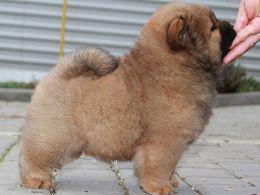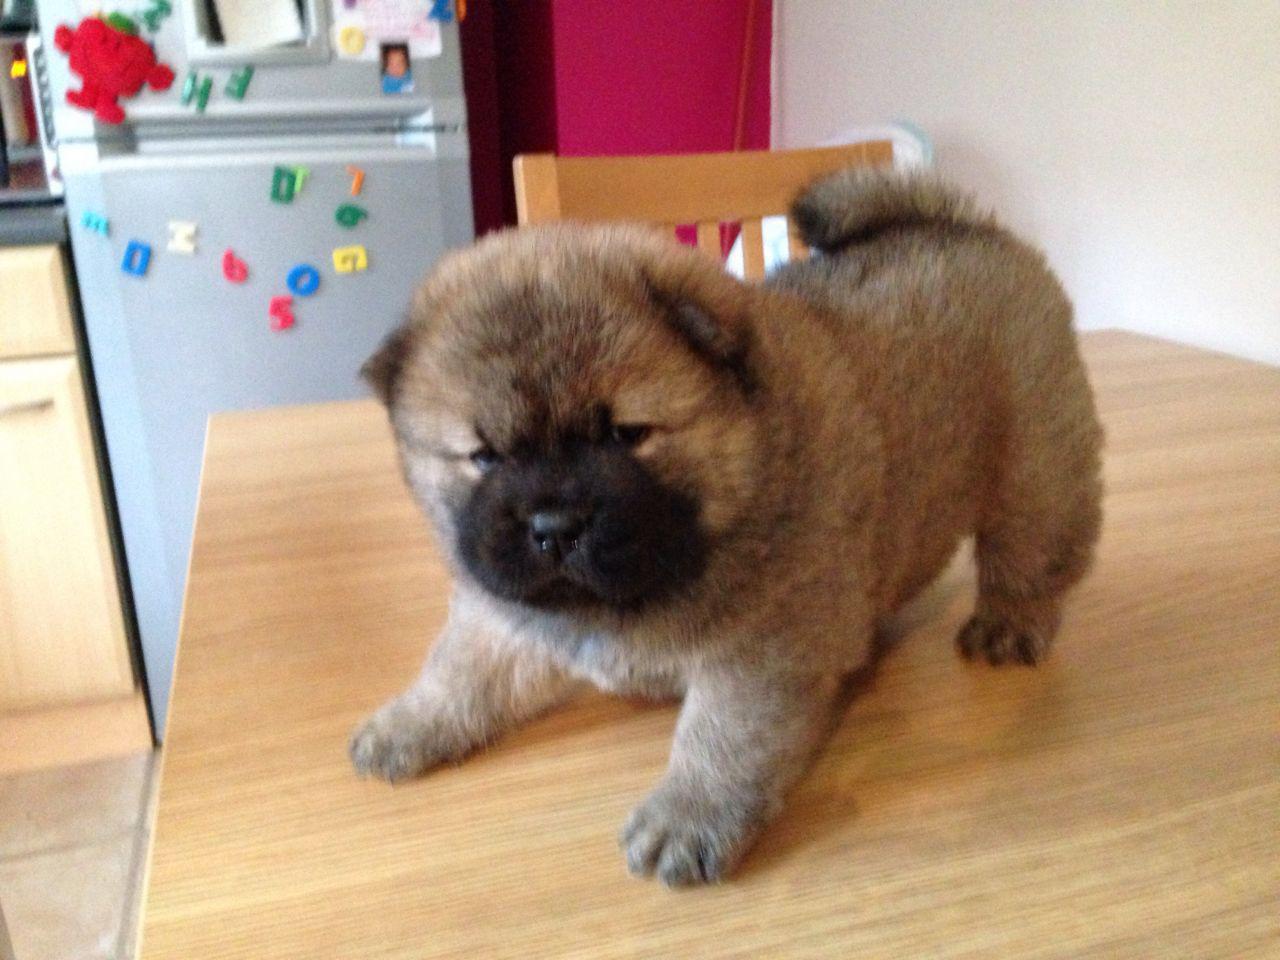The first image is the image on the left, the second image is the image on the right. Given the left and right images, does the statement "The dog in the image on the right is positioned on a wooden surface." hold true? Answer yes or no. Yes. The first image is the image on the left, the second image is the image on the right. Examine the images to the left and right. Is the description "All dogs shown are chow puppies, one puppy is standing with its body in profile, one puppy has its front paws extended, and at least one of the puppies has a black muzzle." accurate? Answer yes or no. Yes. 